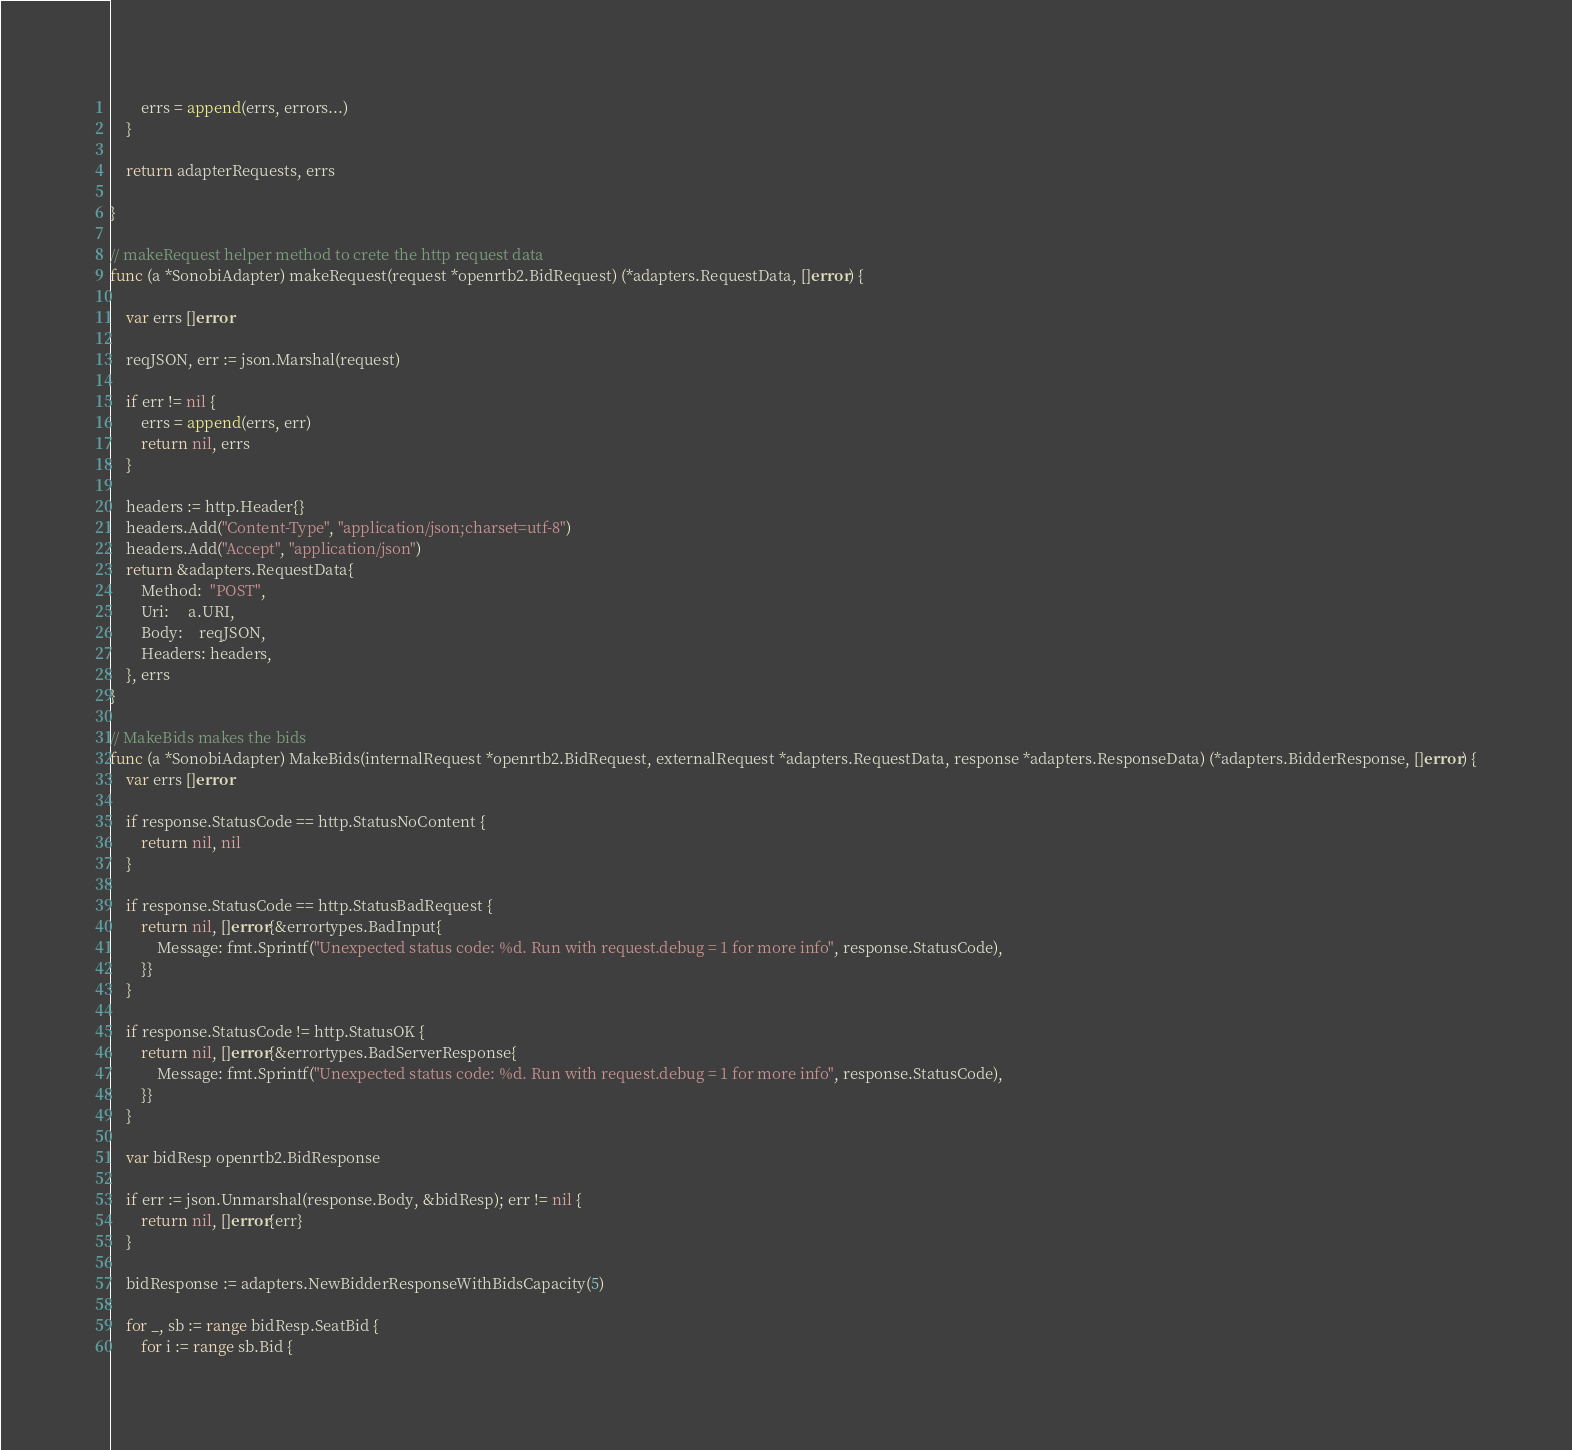Convert code to text. <code><loc_0><loc_0><loc_500><loc_500><_Go_>		errs = append(errs, errors...)
	}

	return adapterRequests, errs

}

// makeRequest helper method to crete the http request data
func (a *SonobiAdapter) makeRequest(request *openrtb2.BidRequest) (*adapters.RequestData, []error) {

	var errs []error

	reqJSON, err := json.Marshal(request)

	if err != nil {
		errs = append(errs, err)
		return nil, errs
	}

	headers := http.Header{}
	headers.Add("Content-Type", "application/json;charset=utf-8")
	headers.Add("Accept", "application/json")
	return &adapters.RequestData{
		Method:  "POST",
		Uri:     a.URI,
		Body:    reqJSON,
		Headers: headers,
	}, errs
}

// MakeBids makes the bids
func (a *SonobiAdapter) MakeBids(internalRequest *openrtb2.BidRequest, externalRequest *adapters.RequestData, response *adapters.ResponseData) (*adapters.BidderResponse, []error) {
	var errs []error

	if response.StatusCode == http.StatusNoContent {
		return nil, nil
	}

	if response.StatusCode == http.StatusBadRequest {
		return nil, []error{&errortypes.BadInput{
			Message: fmt.Sprintf("Unexpected status code: %d. Run with request.debug = 1 for more info", response.StatusCode),
		}}
	}

	if response.StatusCode != http.StatusOK {
		return nil, []error{&errortypes.BadServerResponse{
			Message: fmt.Sprintf("Unexpected status code: %d. Run with request.debug = 1 for more info", response.StatusCode),
		}}
	}

	var bidResp openrtb2.BidResponse

	if err := json.Unmarshal(response.Body, &bidResp); err != nil {
		return nil, []error{err}
	}

	bidResponse := adapters.NewBidderResponseWithBidsCapacity(5)

	for _, sb := range bidResp.SeatBid {
		for i := range sb.Bid {</code> 